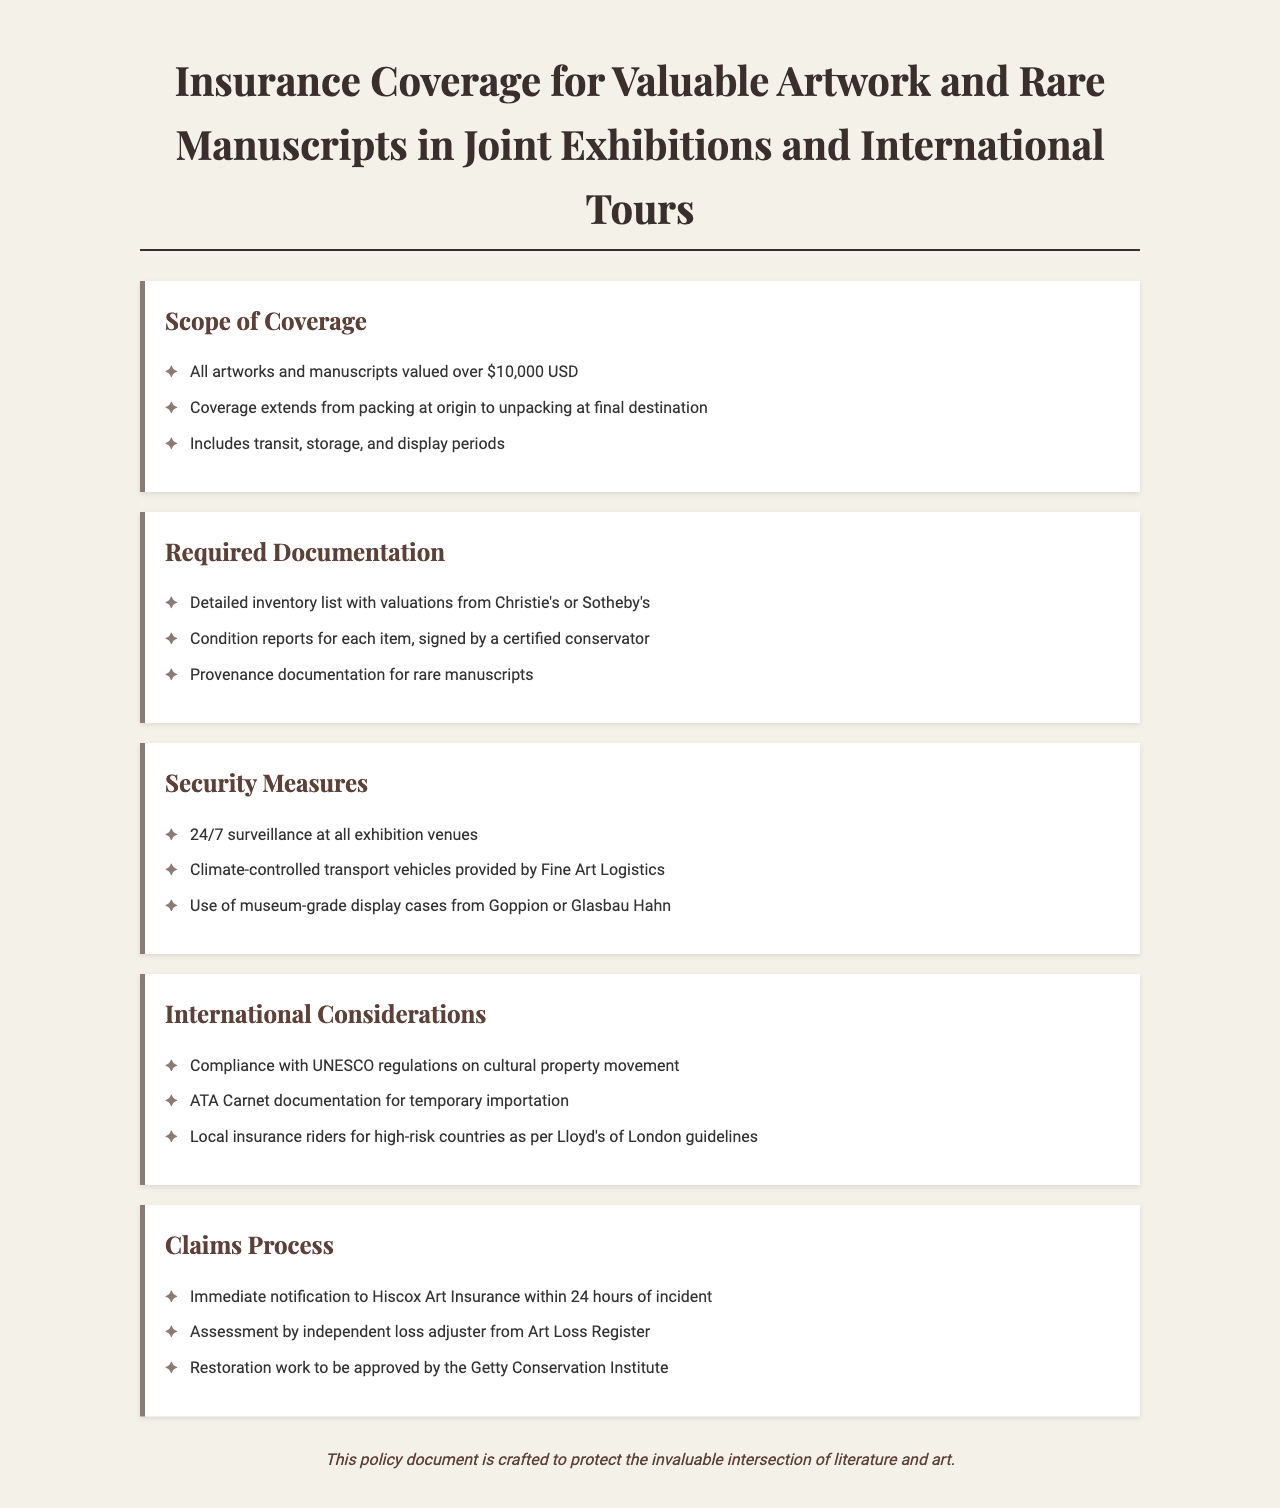What is the minimum value for artworks to be covered? The document specifies that all artworks and manuscripts valued over $10,000 USD are covered.
Answer: $10,000 USD What must be included in the inventory list? The required documentation states that a detailed inventory list with valuations from Christie's or Sotheby's must be included.
Answer: Valuations from Christie's or Sotheby's Who should sign the condition reports for each item? The document requires that condition reports be signed by a certified conservator.
Answer: Certified conservator What type of display cases are required for exhibitions? The security measures include the use of museum-grade display cases from Goppion or Glasbau Hahn.
Answer: Museum-grade display cases What is the time frame for notifying the insurance provider in case of an incident? The claims process states that there should be an immediate notification to Hiscox Art Insurance within 24 hours of the incident.
Answer: 24 hours What documentation is necessary for international tours? The policy mentions that ATA Carnet documentation is required for temporary importation during international tours.
Answer: ATA Carnet documentation What entity assesses claims after an incident occurs? According to the claims process, the assessment is done by an independent loss adjuster from Art Loss Register.
Answer: Art Loss Register What security measure is mandated at all exhibition venues? The document outlines that 24/7 surveillance is a required security measure at all exhibition venues.
Answer: 24/7 surveillance What cultural regulations must be complied with during international tours? The document specifies compliance with UNESCO regulations on cultural property movement for international considerations.
Answer: UNESCO regulations 